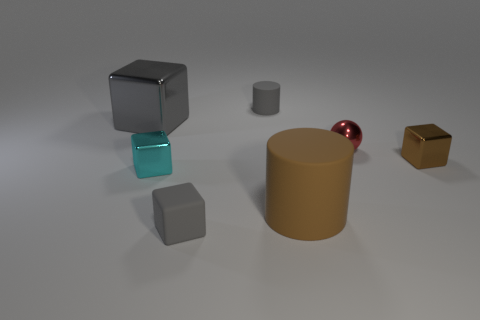There is a gray rubber thing that is behind the small gray matte object on the left side of the matte cylinder behind the gray metallic cube; how big is it?
Make the answer very short. Small. What number of other things are the same shape as the tiny red object?
Ensure brevity in your answer.  0. The shiny cube that is in front of the big metallic thing and behind the tiny cyan thing is what color?
Ensure brevity in your answer.  Brown. There is a matte cylinder that is behind the brown cylinder; is it the same color as the rubber block?
Provide a succinct answer. Yes. What number of cylinders are gray rubber things or small objects?
Offer a very short reply. 1. There is a tiny rubber thing to the right of the matte block; what is its shape?
Keep it short and to the point. Cylinder. There is a block that is behind the tiny block on the right side of the small gray rubber thing in front of the big rubber cylinder; what color is it?
Provide a short and direct response. Gray. Is the small brown cube made of the same material as the small gray block?
Provide a short and direct response. No. How many cyan objects are cubes or tiny rubber blocks?
Offer a terse response. 1. There is a small red sphere; how many brown rubber cylinders are behind it?
Offer a terse response. 0. 